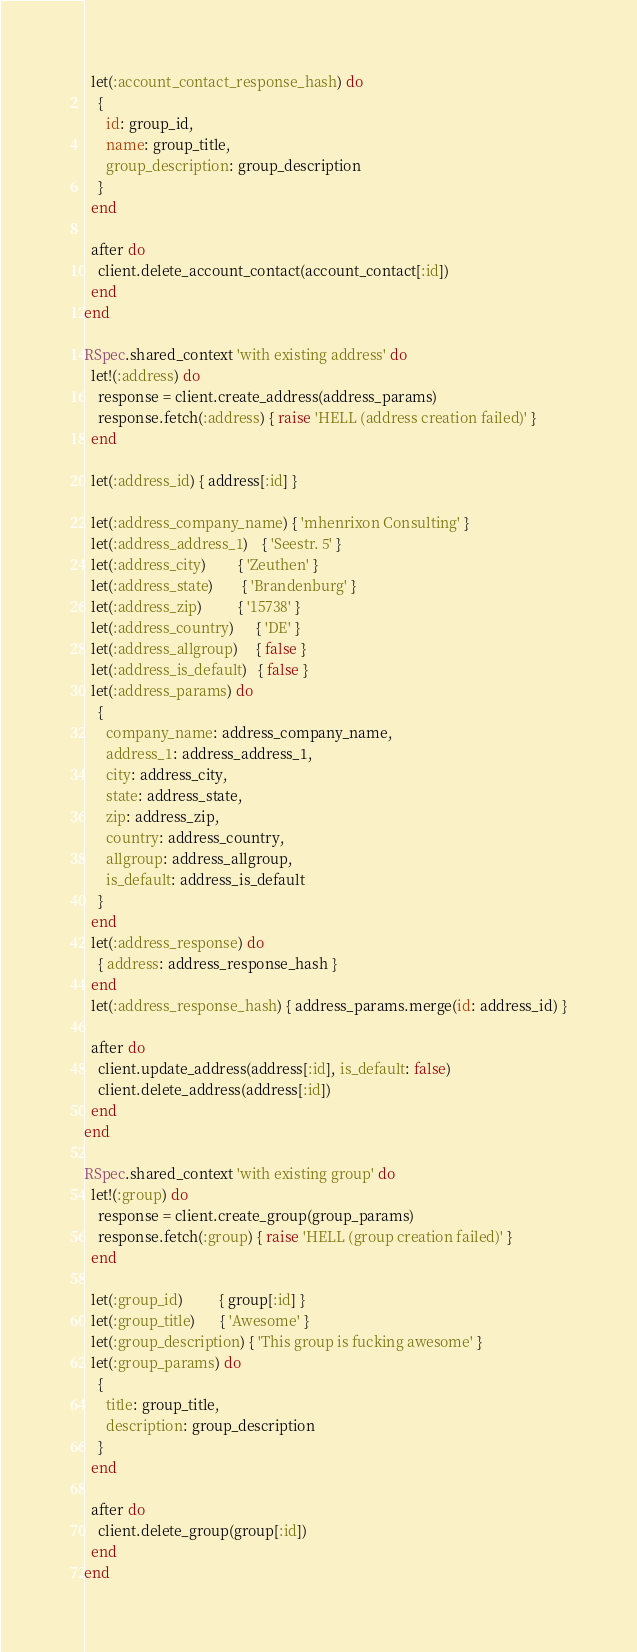<code> <loc_0><loc_0><loc_500><loc_500><_Ruby_>  let(:account_contact_response_hash) do
    {
      id: group_id,
      name: group_title,
      group_description: group_description
    }
  end

  after do
    client.delete_account_contact(account_contact[:id])
  end
end

RSpec.shared_context 'with existing address' do
  let!(:address) do
    response = client.create_address(address_params)
    response.fetch(:address) { raise 'HELL (address creation failed)' }
  end

  let(:address_id) { address[:id] }

  let(:address_company_name) { 'mhenrixon Consulting' }
  let(:address_address_1)    { 'Seestr. 5' }
  let(:address_city)         { 'Zeuthen' }
  let(:address_state)        { 'Brandenburg' }
  let(:address_zip)          { '15738' }
  let(:address_country)      { 'DE' }
  let(:address_allgroup)     { false }
  let(:address_is_default)   { false }
  let(:address_params) do
    {
      company_name: address_company_name,
      address_1: address_address_1,
      city: address_city,
      state: address_state,
      zip: address_zip,
      country: address_country,
      allgroup: address_allgroup,
      is_default: address_is_default
    }
  end
  let(:address_response) do
    { address: address_response_hash }
  end
  let(:address_response_hash) { address_params.merge(id: address_id) }

  after do
    client.update_address(address[:id], is_default: false)
    client.delete_address(address[:id])
  end
end

RSpec.shared_context 'with existing group' do
  let!(:group) do
    response = client.create_group(group_params)
    response.fetch(:group) { raise 'HELL (group creation failed)' }
  end

  let(:group_id)          { group[:id] }
  let(:group_title)       { 'Awesome' }
  let(:group_description) { 'This group is fucking awesome' }
  let(:group_params) do
    {
      title: group_title,
      description: group_description
    }
  end

  after do
    client.delete_group(group[:id])
  end
end
</code> 